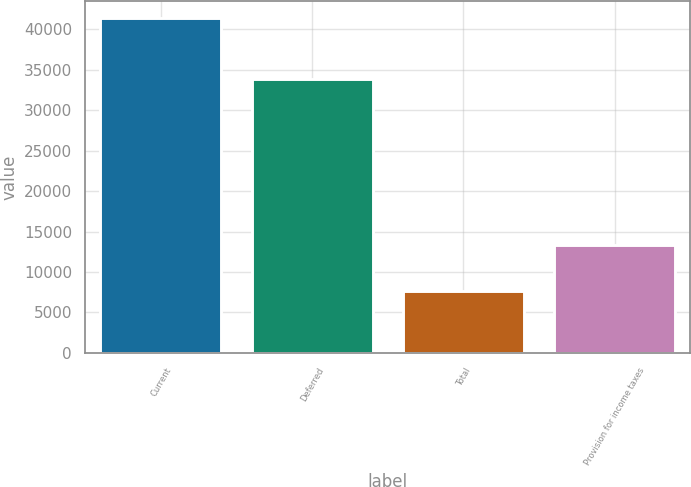Convert chart. <chart><loc_0><loc_0><loc_500><loc_500><bar_chart><fcel>Current<fcel>Deferred<fcel>Total<fcel>Provision for income taxes<nl><fcel>41425<fcel>33819<fcel>7606<fcel>13372<nl></chart> 